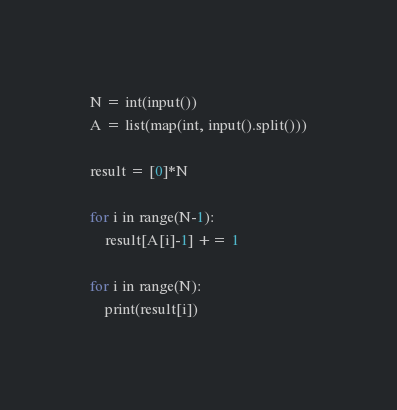<code> <loc_0><loc_0><loc_500><loc_500><_Python_>N = int(input())
A = list(map(int, input().split()))
 
result = [0]*N
 
for i in range(N-1):
    result[A[i]-1] += 1
 
for i in range(N):
    print(result[i])</code> 